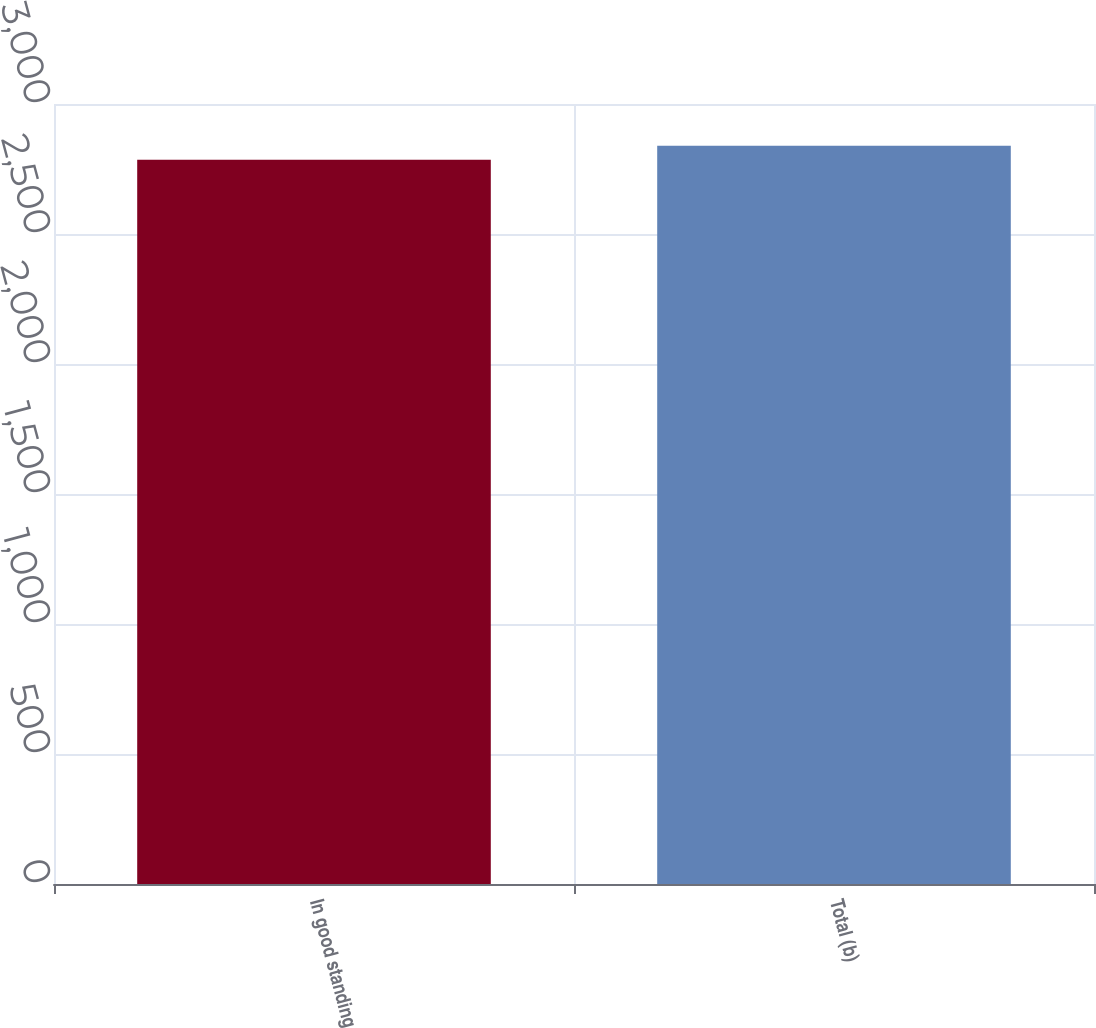Convert chart. <chart><loc_0><loc_0><loc_500><loc_500><bar_chart><fcel>In good standing<fcel>Total (b)<nl><fcel>2786<fcel>2839<nl></chart> 